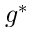Convert formula to latex. <formula><loc_0><loc_0><loc_500><loc_500>g ^ { * }</formula> 